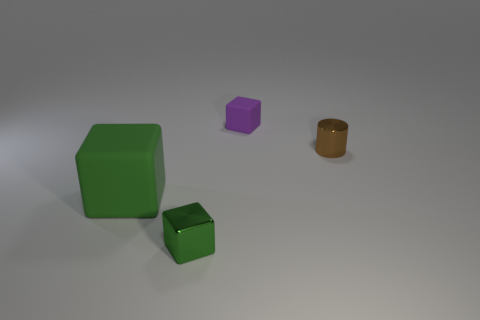Subtract all brown spheres. How many green blocks are left? 2 Subtract all small cubes. How many cubes are left? 1 Add 1 purple cubes. How many objects exist? 5 Subtract 1 blocks. How many blocks are left? 2 Subtract all cylinders. How many objects are left? 3 Add 4 rubber cubes. How many rubber cubes exist? 6 Subtract 0 purple spheres. How many objects are left? 4 Subtract all gray matte blocks. Subtract all green blocks. How many objects are left? 2 Add 4 metallic cylinders. How many metallic cylinders are left? 5 